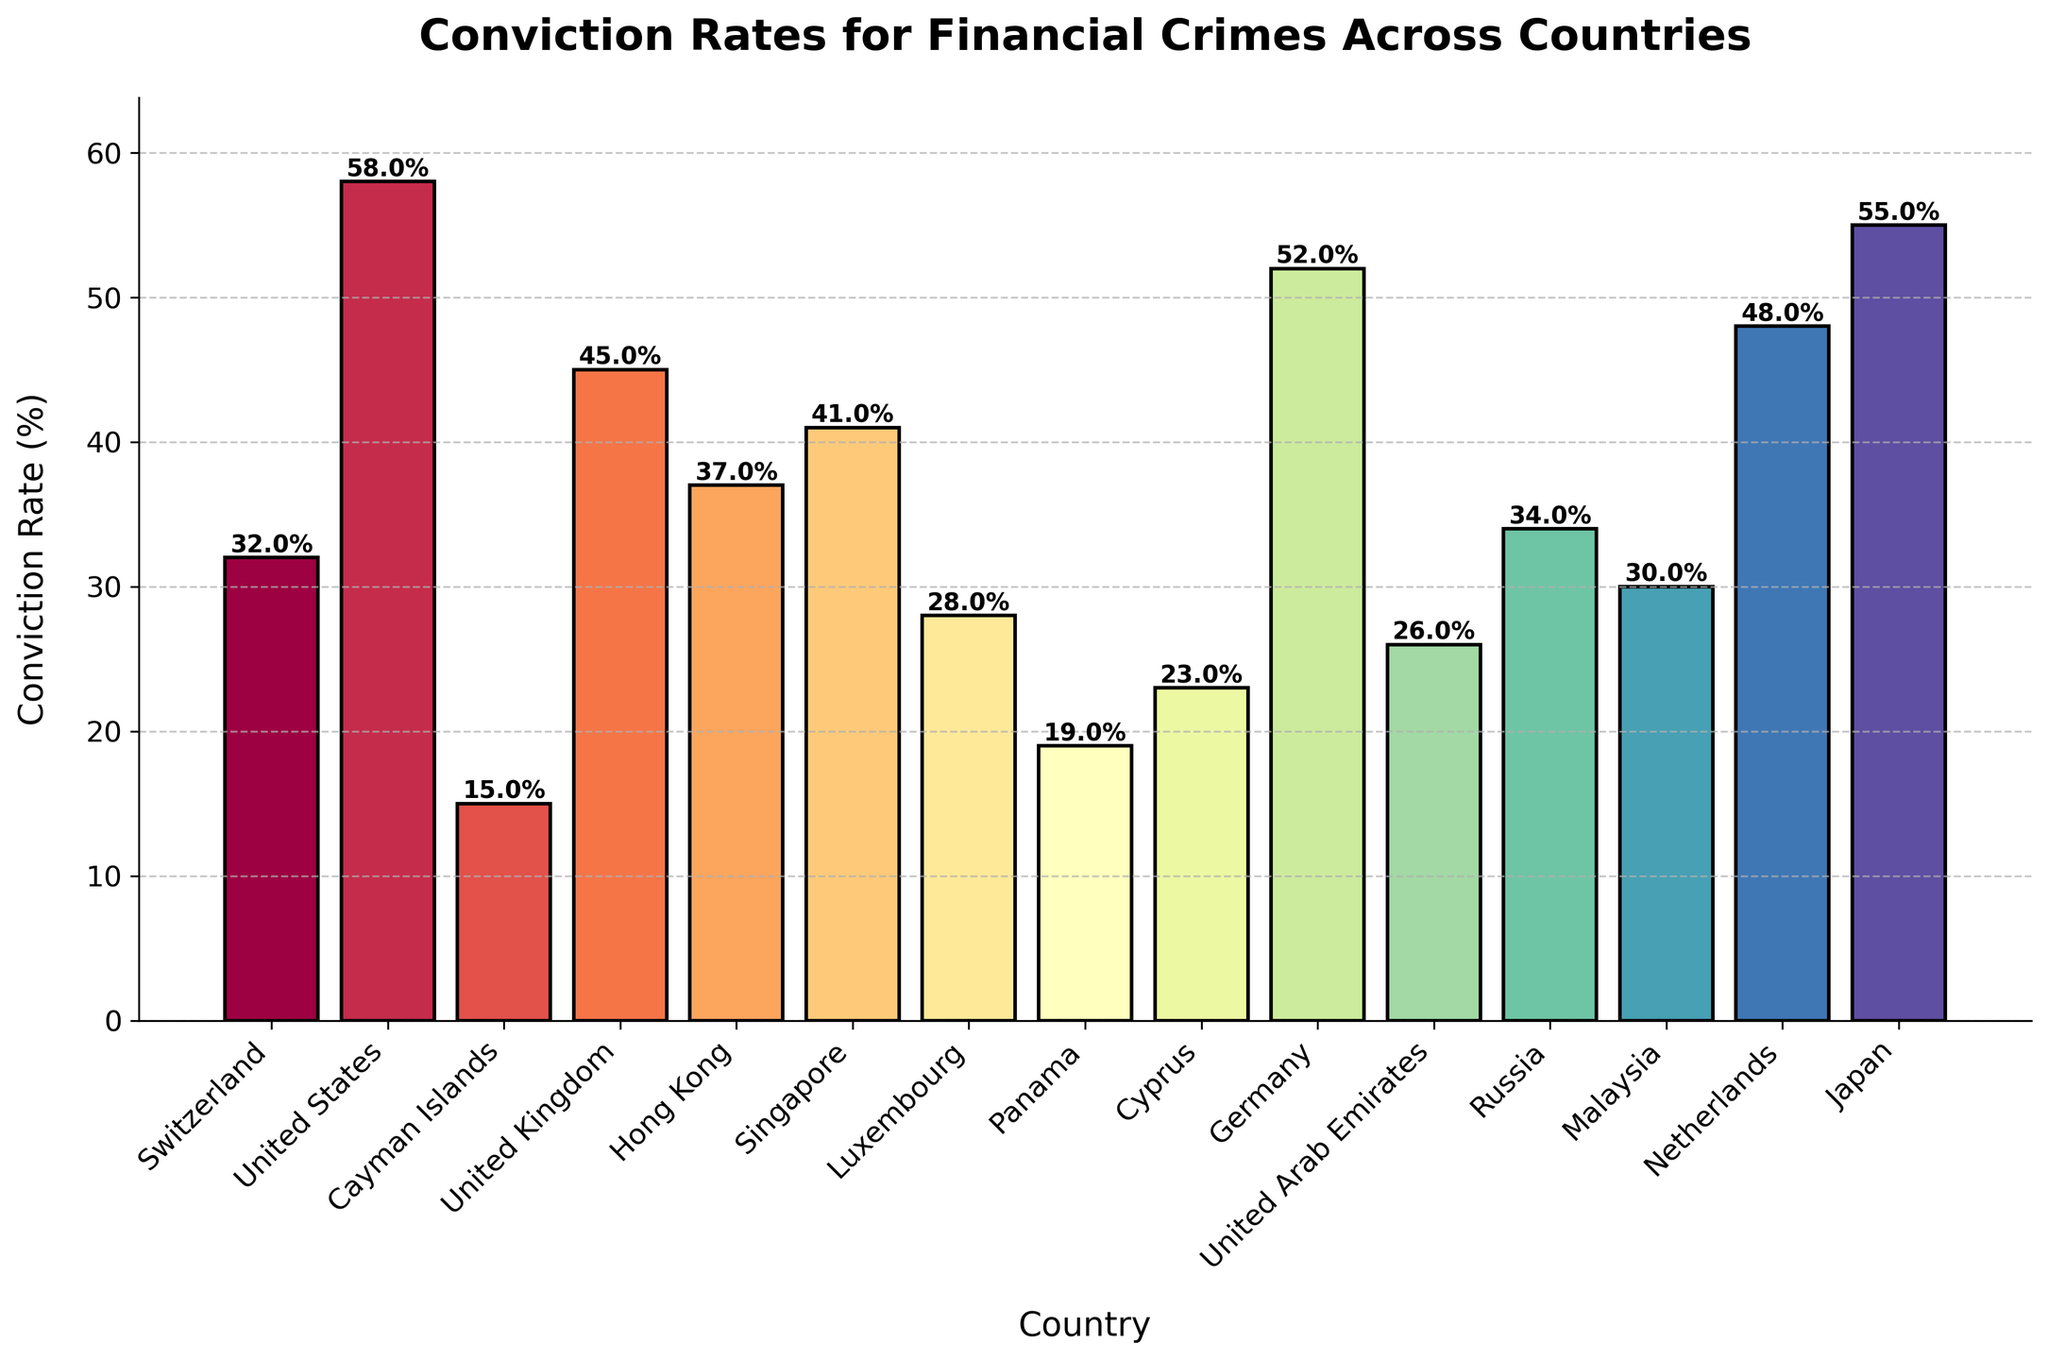What's the highest conviction rate among all countries? To determine the highest conviction rate, we examine the heights of the bars and identify the tallest one. The tallest bar corresponds to the United States with a conviction rate of 58%.
Answer: 58% Which country has the lowest conviction rate? To identify the lowest conviction rate, we look for the shortest bar on the chart. The shortest bar belongs to the Cayman Islands with a conviction rate of 15%.
Answer: Cayman Islands How does the conviction rate in the United Kingdom compare to that in Germany? We compare the heights of the bars for the United Kingdom and Germany. The United Kingdom has a conviction rate of 45%, while Germany has a higher rate of 52%. Therefore, the conviction rate in Germany is greater than in the United Kingdom.
Answer: Germany has a higher conviction rate than the United Kingdom What is the average conviction rate across all countries? To calculate the average, we sum up all the conviction rates and divide by the number of countries. The sum of the rates is 548% for 15 countries. So, the average is 548 / 15  = 36.53%.
Answer: 36.53% What's the difference in conviction rates between Japan and Russia? To find the difference, we subtract the conviction rate of Russia (34%) from that of Japan (55%). This gives us a difference of 21%.
Answer: 21% Is the conviction rate of Hong Kong closer to that of Switzerland or Singapore? We compare the conviction rate of Hong Kong (37%) to both Switzerland (32%) and Singapore (41%). The difference between Hong Kong and Switzerland is 5%, while the difference between Hong Kong and Singapore is 4%. Thus, Hong Kong's conviction rate is closer to that of Singapore.
Answer: Singapore How many countries have a conviction rate above 50%? We count the number of bars that exceed the 50% mark. The countries meeting this criterion are the United States, Germany, and Japan, making a total of 3 countries.
Answer: 3 Which countries have conviction rates that are at least 10% lower than the highest rate? The highest rate is 58%. Subtracting 10% from this gives us 48%. We need to find countries with rates below 48%. They are Cayman Islands, Switzerland, Hong Kong, Singapore, Luxembourg, Panama, Cyprus, United Arab Emirates, Russia, Malaysia. So, there are 10 such countries.
Answer: 10 What is the median conviction rate of the listed countries? To find the median, we list the conviction rates in ascending order and find the middle value. The ordered rates are 15, 19, 23, 26, 28, 30, 32, 34, 37, 41, 45, 48, 52, 55, 58. The median rate, being the 8th value, is 34%.
Answer: 34% What is the total conviction rate of all countries that have a rate below 30%? We first identify the countries with rates below 30%: Cayman Islands (15%), Panama (19%), Cyprus (23%), United Arab Emirates (26%), Luxembourg (28%). We then sum these rates: 15 + 19 + 23 + 26 + 28 = 111%.
Answer: 111% 